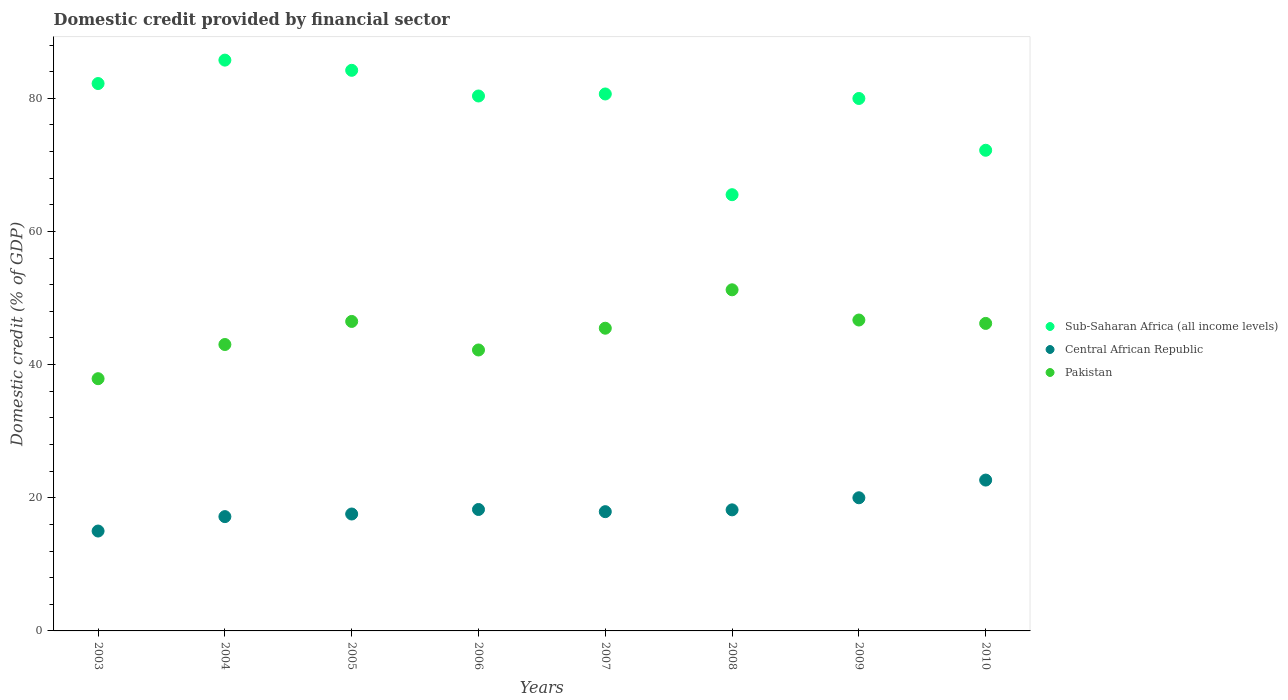How many different coloured dotlines are there?
Your response must be concise. 3. What is the domestic credit in Pakistan in 2006?
Offer a very short reply. 42.2. Across all years, what is the maximum domestic credit in Pakistan?
Offer a very short reply. 51.23. Across all years, what is the minimum domestic credit in Pakistan?
Ensure brevity in your answer.  37.88. What is the total domestic credit in Pakistan in the graph?
Your answer should be compact. 359.16. What is the difference between the domestic credit in Pakistan in 2007 and that in 2009?
Make the answer very short. -1.23. What is the difference between the domestic credit in Sub-Saharan Africa (all income levels) in 2005 and the domestic credit in Central African Republic in 2010?
Ensure brevity in your answer.  61.54. What is the average domestic credit in Pakistan per year?
Your answer should be very brief. 44.9. In the year 2008, what is the difference between the domestic credit in Central African Republic and domestic credit in Pakistan?
Provide a short and direct response. -33.05. In how many years, is the domestic credit in Sub-Saharan Africa (all income levels) greater than 12 %?
Offer a terse response. 8. What is the ratio of the domestic credit in Pakistan in 2006 to that in 2008?
Ensure brevity in your answer.  0.82. Is the difference between the domestic credit in Central African Republic in 2003 and 2010 greater than the difference between the domestic credit in Pakistan in 2003 and 2010?
Offer a terse response. Yes. What is the difference between the highest and the second highest domestic credit in Central African Republic?
Keep it short and to the point. 2.66. What is the difference between the highest and the lowest domestic credit in Central African Republic?
Give a very brief answer. 7.65. In how many years, is the domestic credit in Central African Republic greater than the average domestic credit in Central African Republic taken over all years?
Provide a succinct answer. 2. Is the sum of the domestic credit in Pakistan in 2007 and 2010 greater than the maximum domestic credit in Sub-Saharan Africa (all income levels) across all years?
Give a very brief answer. Yes. Does the domestic credit in Sub-Saharan Africa (all income levels) monotonically increase over the years?
Give a very brief answer. No. Is the domestic credit in Pakistan strictly less than the domestic credit in Sub-Saharan Africa (all income levels) over the years?
Your answer should be very brief. Yes. How many years are there in the graph?
Ensure brevity in your answer.  8. What is the difference between two consecutive major ticks on the Y-axis?
Provide a succinct answer. 20. Does the graph contain any zero values?
Your answer should be very brief. No. Does the graph contain grids?
Provide a short and direct response. No. Where does the legend appear in the graph?
Your answer should be compact. Center right. What is the title of the graph?
Offer a terse response. Domestic credit provided by financial sector. What is the label or title of the Y-axis?
Provide a succinct answer. Domestic credit (% of GDP). What is the Domestic credit (% of GDP) of Sub-Saharan Africa (all income levels) in 2003?
Provide a succinct answer. 82.22. What is the Domestic credit (% of GDP) of Central African Republic in 2003?
Provide a succinct answer. 15. What is the Domestic credit (% of GDP) in Pakistan in 2003?
Your answer should be compact. 37.88. What is the Domestic credit (% of GDP) in Sub-Saharan Africa (all income levels) in 2004?
Your answer should be very brief. 85.73. What is the Domestic credit (% of GDP) of Central African Republic in 2004?
Offer a terse response. 17.17. What is the Domestic credit (% of GDP) of Pakistan in 2004?
Ensure brevity in your answer.  43.02. What is the Domestic credit (% of GDP) in Sub-Saharan Africa (all income levels) in 2005?
Make the answer very short. 84.2. What is the Domestic credit (% of GDP) in Central African Republic in 2005?
Keep it short and to the point. 17.56. What is the Domestic credit (% of GDP) in Pakistan in 2005?
Make the answer very short. 46.48. What is the Domestic credit (% of GDP) of Sub-Saharan Africa (all income levels) in 2006?
Give a very brief answer. 80.34. What is the Domestic credit (% of GDP) of Central African Republic in 2006?
Your answer should be compact. 18.24. What is the Domestic credit (% of GDP) of Pakistan in 2006?
Offer a very short reply. 42.2. What is the Domestic credit (% of GDP) of Sub-Saharan Africa (all income levels) in 2007?
Your answer should be very brief. 80.65. What is the Domestic credit (% of GDP) of Central African Republic in 2007?
Your answer should be compact. 17.91. What is the Domestic credit (% of GDP) in Pakistan in 2007?
Keep it short and to the point. 45.46. What is the Domestic credit (% of GDP) of Sub-Saharan Africa (all income levels) in 2008?
Ensure brevity in your answer.  65.52. What is the Domestic credit (% of GDP) of Central African Republic in 2008?
Ensure brevity in your answer.  18.18. What is the Domestic credit (% of GDP) in Pakistan in 2008?
Give a very brief answer. 51.23. What is the Domestic credit (% of GDP) of Sub-Saharan Africa (all income levels) in 2009?
Your response must be concise. 79.97. What is the Domestic credit (% of GDP) of Central African Republic in 2009?
Offer a terse response. 20. What is the Domestic credit (% of GDP) of Pakistan in 2009?
Offer a very short reply. 46.7. What is the Domestic credit (% of GDP) of Sub-Saharan Africa (all income levels) in 2010?
Make the answer very short. 72.19. What is the Domestic credit (% of GDP) of Central African Republic in 2010?
Keep it short and to the point. 22.66. What is the Domestic credit (% of GDP) in Pakistan in 2010?
Keep it short and to the point. 46.19. Across all years, what is the maximum Domestic credit (% of GDP) of Sub-Saharan Africa (all income levels)?
Your answer should be compact. 85.73. Across all years, what is the maximum Domestic credit (% of GDP) of Central African Republic?
Your response must be concise. 22.66. Across all years, what is the maximum Domestic credit (% of GDP) in Pakistan?
Your answer should be very brief. 51.23. Across all years, what is the minimum Domestic credit (% of GDP) of Sub-Saharan Africa (all income levels)?
Your response must be concise. 65.52. Across all years, what is the minimum Domestic credit (% of GDP) in Central African Republic?
Ensure brevity in your answer.  15. Across all years, what is the minimum Domestic credit (% of GDP) in Pakistan?
Keep it short and to the point. 37.88. What is the total Domestic credit (% of GDP) in Sub-Saharan Africa (all income levels) in the graph?
Give a very brief answer. 630.82. What is the total Domestic credit (% of GDP) of Central African Republic in the graph?
Your answer should be very brief. 146.72. What is the total Domestic credit (% of GDP) of Pakistan in the graph?
Provide a succinct answer. 359.16. What is the difference between the Domestic credit (% of GDP) in Sub-Saharan Africa (all income levels) in 2003 and that in 2004?
Offer a terse response. -3.52. What is the difference between the Domestic credit (% of GDP) of Central African Republic in 2003 and that in 2004?
Give a very brief answer. -2.17. What is the difference between the Domestic credit (% of GDP) of Pakistan in 2003 and that in 2004?
Ensure brevity in your answer.  -5.13. What is the difference between the Domestic credit (% of GDP) of Sub-Saharan Africa (all income levels) in 2003 and that in 2005?
Your response must be concise. -1.99. What is the difference between the Domestic credit (% of GDP) in Central African Republic in 2003 and that in 2005?
Keep it short and to the point. -2.56. What is the difference between the Domestic credit (% of GDP) in Pakistan in 2003 and that in 2005?
Ensure brevity in your answer.  -8.6. What is the difference between the Domestic credit (% of GDP) of Sub-Saharan Africa (all income levels) in 2003 and that in 2006?
Your response must be concise. 1.87. What is the difference between the Domestic credit (% of GDP) of Central African Republic in 2003 and that in 2006?
Ensure brevity in your answer.  -3.24. What is the difference between the Domestic credit (% of GDP) of Pakistan in 2003 and that in 2006?
Your answer should be compact. -4.31. What is the difference between the Domestic credit (% of GDP) in Sub-Saharan Africa (all income levels) in 2003 and that in 2007?
Your answer should be compact. 1.57. What is the difference between the Domestic credit (% of GDP) of Central African Republic in 2003 and that in 2007?
Your response must be concise. -2.91. What is the difference between the Domestic credit (% of GDP) of Pakistan in 2003 and that in 2007?
Provide a succinct answer. -7.58. What is the difference between the Domestic credit (% of GDP) in Sub-Saharan Africa (all income levels) in 2003 and that in 2008?
Provide a short and direct response. 16.69. What is the difference between the Domestic credit (% of GDP) in Central African Republic in 2003 and that in 2008?
Offer a very short reply. -3.18. What is the difference between the Domestic credit (% of GDP) of Pakistan in 2003 and that in 2008?
Ensure brevity in your answer.  -13.35. What is the difference between the Domestic credit (% of GDP) in Sub-Saharan Africa (all income levels) in 2003 and that in 2009?
Your response must be concise. 2.24. What is the difference between the Domestic credit (% of GDP) in Central African Republic in 2003 and that in 2009?
Offer a terse response. -5. What is the difference between the Domestic credit (% of GDP) in Pakistan in 2003 and that in 2009?
Your answer should be very brief. -8.81. What is the difference between the Domestic credit (% of GDP) in Sub-Saharan Africa (all income levels) in 2003 and that in 2010?
Ensure brevity in your answer.  10.02. What is the difference between the Domestic credit (% of GDP) of Central African Republic in 2003 and that in 2010?
Give a very brief answer. -7.65. What is the difference between the Domestic credit (% of GDP) of Pakistan in 2003 and that in 2010?
Ensure brevity in your answer.  -8.3. What is the difference between the Domestic credit (% of GDP) of Sub-Saharan Africa (all income levels) in 2004 and that in 2005?
Your response must be concise. 1.53. What is the difference between the Domestic credit (% of GDP) in Central African Republic in 2004 and that in 2005?
Provide a short and direct response. -0.39. What is the difference between the Domestic credit (% of GDP) of Pakistan in 2004 and that in 2005?
Your response must be concise. -3.46. What is the difference between the Domestic credit (% of GDP) of Sub-Saharan Africa (all income levels) in 2004 and that in 2006?
Keep it short and to the point. 5.39. What is the difference between the Domestic credit (% of GDP) of Central African Republic in 2004 and that in 2006?
Your response must be concise. -1.07. What is the difference between the Domestic credit (% of GDP) of Pakistan in 2004 and that in 2006?
Keep it short and to the point. 0.82. What is the difference between the Domestic credit (% of GDP) in Sub-Saharan Africa (all income levels) in 2004 and that in 2007?
Your response must be concise. 5.08. What is the difference between the Domestic credit (% of GDP) in Central African Republic in 2004 and that in 2007?
Make the answer very short. -0.74. What is the difference between the Domestic credit (% of GDP) in Pakistan in 2004 and that in 2007?
Offer a terse response. -2.45. What is the difference between the Domestic credit (% of GDP) of Sub-Saharan Africa (all income levels) in 2004 and that in 2008?
Offer a terse response. 20.21. What is the difference between the Domestic credit (% of GDP) in Central African Republic in 2004 and that in 2008?
Offer a terse response. -1.02. What is the difference between the Domestic credit (% of GDP) of Pakistan in 2004 and that in 2008?
Keep it short and to the point. -8.22. What is the difference between the Domestic credit (% of GDP) in Sub-Saharan Africa (all income levels) in 2004 and that in 2009?
Offer a very short reply. 5.76. What is the difference between the Domestic credit (% of GDP) in Central African Republic in 2004 and that in 2009?
Provide a short and direct response. -2.83. What is the difference between the Domestic credit (% of GDP) of Pakistan in 2004 and that in 2009?
Offer a terse response. -3.68. What is the difference between the Domestic credit (% of GDP) of Sub-Saharan Africa (all income levels) in 2004 and that in 2010?
Offer a terse response. 13.54. What is the difference between the Domestic credit (% of GDP) of Central African Republic in 2004 and that in 2010?
Your answer should be very brief. -5.49. What is the difference between the Domestic credit (% of GDP) of Pakistan in 2004 and that in 2010?
Provide a succinct answer. -3.17. What is the difference between the Domestic credit (% of GDP) in Sub-Saharan Africa (all income levels) in 2005 and that in 2006?
Give a very brief answer. 3.86. What is the difference between the Domestic credit (% of GDP) in Central African Republic in 2005 and that in 2006?
Ensure brevity in your answer.  -0.68. What is the difference between the Domestic credit (% of GDP) of Pakistan in 2005 and that in 2006?
Make the answer very short. 4.29. What is the difference between the Domestic credit (% of GDP) in Sub-Saharan Africa (all income levels) in 2005 and that in 2007?
Your response must be concise. 3.55. What is the difference between the Domestic credit (% of GDP) of Central African Republic in 2005 and that in 2007?
Your answer should be compact. -0.35. What is the difference between the Domestic credit (% of GDP) in Pakistan in 2005 and that in 2007?
Keep it short and to the point. 1.02. What is the difference between the Domestic credit (% of GDP) of Sub-Saharan Africa (all income levels) in 2005 and that in 2008?
Your answer should be very brief. 18.68. What is the difference between the Domestic credit (% of GDP) of Central African Republic in 2005 and that in 2008?
Offer a terse response. -0.63. What is the difference between the Domestic credit (% of GDP) in Pakistan in 2005 and that in 2008?
Your answer should be very brief. -4.75. What is the difference between the Domestic credit (% of GDP) of Sub-Saharan Africa (all income levels) in 2005 and that in 2009?
Your response must be concise. 4.23. What is the difference between the Domestic credit (% of GDP) of Central African Republic in 2005 and that in 2009?
Keep it short and to the point. -2.44. What is the difference between the Domestic credit (% of GDP) in Pakistan in 2005 and that in 2009?
Your answer should be very brief. -0.21. What is the difference between the Domestic credit (% of GDP) of Sub-Saharan Africa (all income levels) in 2005 and that in 2010?
Your answer should be very brief. 12.01. What is the difference between the Domestic credit (% of GDP) of Central African Republic in 2005 and that in 2010?
Ensure brevity in your answer.  -5.1. What is the difference between the Domestic credit (% of GDP) of Pakistan in 2005 and that in 2010?
Offer a terse response. 0.3. What is the difference between the Domestic credit (% of GDP) of Sub-Saharan Africa (all income levels) in 2006 and that in 2007?
Ensure brevity in your answer.  -0.3. What is the difference between the Domestic credit (% of GDP) of Central African Republic in 2006 and that in 2007?
Make the answer very short. 0.33. What is the difference between the Domestic credit (% of GDP) in Pakistan in 2006 and that in 2007?
Offer a very short reply. -3.27. What is the difference between the Domestic credit (% of GDP) of Sub-Saharan Africa (all income levels) in 2006 and that in 2008?
Ensure brevity in your answer.  14.82. What is the difference between the Domestic credit (% of GDP) in Central African Republic in 2006 and that in 2008?
Your answer should be compact. 0.05. What is the difference between the Domestic credit (% of GDP) of Pakistan in 2006 and that in 2008?
Keep it short and to the point. -9.04. What is the difference between the Domestic credit (% of GDP) in Sub-Saharan Africa (all income levels) in 2006 and that in 2009?
Ensure brevity in your answer.  0.37. What is the difference between the Domestic credit (% of GDP) in Central African Republic in 2006 and that in 2009?
Give a very brief answer. -1.76. What is the difference between the Domestic credit (% of GDP) in Pakistan in 2006 and that in 2009?
Offer a very short reply. -4.5. What is the difference between the Domestic credit (% of GDP) in Sub-Saharan Africa (all income levels) in 2006 and that in 2010?
Ensure brevity in your answer.  8.15. What is the difference between the Domestic credit (% of GDP) in Central African Republic in 2006 and that in 2010?
Offer a very short reply. -4.42. What is the difference between the Domestic credit (% of GDP) of Pakistan in 2006 and that in 2010?
Offer a terse response. -3.99. What is the difference between the Domestic credit (% of GDP) in Sub-Saharan Africa (all income levels) in 2007 and that in 2008?
Your answer should be compact. 15.13. What is the difference between the Domestic credit (% of GDP) of Central African Republic in 2007 and that in 2008?
Keep it short and to the point. -0.27. What is the difference between the Domestic credit (% of GDP) in Pakistan in 2007 and that in 2008?
Make the answer very short. -5.77. What is the difference between the Domestic credit (% of GDP) of Sub-Saharan Africa (all income levels) in 2007 and that in 2009?
Your answer should be very brief. 0.68. What is the difference between the Domestic credit (% of GDP) in Central African Republic in 2007 and that in 2009?
Provide a succinct answer. -2.09. What is the difference between the Domestic credit (% of GDP) of Pakistan in 2007 and that in 2009?
Offer a terse response. -1.23. What is the difference between the Domestic credit (% of GDP) of Sub-Saharan Africa (all income levels) in 2007 and that in 2010?
Your answer should be compact. 8.45. What is the difference between the Domestic credit (% of GDP) of Central African Republic in 2007 and that in 2010?
Make the answer very short. -4.75. What is the difference between the Domestic credit (% of GDP) of Pakistan in 2007 and that in 2010?
Your response must be concise. -0.72. What is the difference between the Domestic credit (% of GDP) of Sub-Saharan Africa (all income levels) in 2008 and that in 2009?
Your answer should be compact. -14.45. What is the difference between the Domestic credit (% of GDP) of Central African Republic in 2008 and that in 2009?
Provide a short and direct response. -1.81. What is the difference between the Domestic credit (% of GDP) of Pakistan in 2008 and that in 2009?
Give a very brief answer. 4.54. What is the difference between the Domestic credit (% of GDP) of Sub-Saharan Africa (all income levels) in 2008 and that in 2010?
Offer a very short reply. -6.67. What is the difference between the Domestic credit (% of GDP) of Central African Republic in 2008 and that in 2010?
Your answer should be very brief. -4.47. What is the difference between the Domestic credit (% of GDP) of Pakistan in 2008 and that in 2010?
Offer a very short reply. 5.05. What is the difference between the Domestic credit (% of GDP) of Sub-Saharan Africa (all income levels) in 2009 and that in 2010?
Provide a short and direct response. 7.78. What is the difference between the Domestic credit (% of GDP) in Central African Republic in 2009 and that in 2010?
Keep it short and to the point. -2.66. What is the difference between the Domestic credit (% of GDP) of Pakistan in 2009 and that in 2010?
Provide a short and direct response. 0.51. What is the difference between the Domestic credit (% of GDP) of Sub-Saharan Africa (all income levels) in 2003 and the Domestic credit (% of GDP) of Central African Republic in 2004?
Offer a terse response. 65.05. What is the difference between the Domestic credit (% of GDP) in Sub-Saharan Africa (all income levels) in 2003 and the Domestic credit (% of GDP) in Pakistan in 2004?
Offer a very short reply. 39.2. What is the difference between the Domestic credit (% of GDP) of Central African Republic in 2003 and the Domestic credit (% of GDP) of Pakistan in 2004?
Ensure brevity in your answer.  -28.02. What is the difference between the Domestic credit (% of GDP) in Sub-Saharan Africa (all income levels) in 2003 and the Domestic credit (% of GDP) in Central African Republic in 2005?
Your response must be concise. 64.66. What is the difference between the Domestic credit (% of GDP) in Sub-Saharan Africa (all income levels) in 2003 and the Domestic credit (% of GDP) in Pakistan in 2005?
Your answer should be very brief. 35.73. What is the difference between the Domestic credit (% of GDP) in Central African Republic in 2003 and the Domestic credit (% of GDP) in Pakistan in 2005?
Your answer should be very brief. -31.48. What is the difference between the Domestic credit (% of GDP) in Sub-Saharan Africa (all income levels) in 2003 and the Domestic credit (% of GDP) in Central African Republic in 2006?
Keep it short and to the point. 63.98. What is the difference between the Domestic credit (% of GDP) of Sub-Saharan Africa (all income levels) in 2003 and the Domestic credit (% of GDP) of Pakistan in 2006?
Make the answer very short. 40.02. What is the difference between the Domestic credit (% of GDP) in Central African Republic in 2003 and the Domestic credit (% of GDP) in Pakistan in 2006?
Your answer should be very brief. -27.19. What is the difference between the Domestic credit (% of GDP) in Sub-Saharan Africa (all income levels) in 2003 and the Domestic credit (% of GDP) in Central African Republic in 2007?
Your response must be concise. 64.3. What is the difference between the Domestic credit (% of GDP) of Sub-Saharan Africa (all income levels) in 2003 and the Domestic credit (% of GDP) of Pakistan in 2007?
Keep it short and to the point. 36.75. What is the difference between the Domestic credit (% of GDP) in Central African Republic in 2003 and the Domestic credit (% of GDP) in Pakistan in 2007?
Provide a succinct answer. -30.46. What is the difference between the Domestic credit (% of GDP) of Sub-Saharan Africa (all income levels) in 2003 and the Domestic credit (% of GDP) of Central African Republic in 2008?
Ensure brevity in your answer.  64.03. What is the difference between the Domestic credit (% of GDP) in Sub-Saharan Africa (all income levels) in 2003 and the Domestic credit (% of GDP) in Pakistan in 2008?
Keep it short and to the point. 30.98. What is the difference between the Domestic credit (% of GDP) of Central African Republic in 2003 and the Domestic credit (% of GDP) of Pakistan in 2008?
Keep it short and to the point. -36.23. What is the difference between the Domestic credit (% of GDP) of Sub-Saharan Africa (all income levels) in 2003 and the Domestic credit (% of GDP) of Central African Republic in 2009?
Provide a short and direct response. 62.22. What is the difference between the Domestic credit (% of GDP) of Sub-Saharan Africa (all income levels) in 2003 and the Domestic credit (% of GDP) of Pakistan in 2009?
Provide a short and direct response. 35.52. What is the difference between the Domestic credit (% of GDP) in Central African Republic in 2003 and the Domestic credit (% of GDP) in Pakistan in 2009?
Ensure brevity in your answer.  -31.69. What is the difference between the Domestic credit (% of GDP) in Sub-Saharan Africa (all income levels) in 2003 and the Domestic credit (% of GDP) in Central African Republic in 2010?
Your answer should be compact. 59.56. What is the difference between the Domestic credit (% of GDP) in Sub-Saharan Africa (all income levels) in 2003 and the Domestic credit (% of GDP) in Pakistan in 2010?
Ensure brevity in your answer.  36.03. What is the difference between the Domestic credit (% of GDP) of Central African Republic in 2003 and the Domestic credit (% of GDP) of Pakistan in 2010?
Your answer should be compact. -31.18. What is the difference between the Domestic credit (% of GDP) of Sub-Saharan Africa (all income levels) in 2004 and the Domestic credit (% of GDP) of Central African Republic in 2005?
Ensure brevity in your answer.  68.17. What is the difference between the Domestic credit (% of GDP) in Sub-Saharan Africa (all income levels) in 2004 and the Domestic credit (% of GDP) in Pakistan in 2005?
Give a very brief answer. 39.25. What is the difference between the Domestic credit (% of GDP) of Central African Republic in 2004 and the Domestic credit (% of GDP) of Pakistan in 2005?
Offer a terse response. -29.31. What is the difference between the Domestic credit (% of GDP) in Sub-Saharan Africa (all income levels) in 2004 and the Domestic credit (% of GDP) in Central African Republic in 2006?
Offer a terse response. 67.49. What is the difference between the Domestic credit (% of GDP) in Sub-Saharan Africa (all income levels) in 2004 and the Domestic credit (% of GDP) in Pakistan in 2006?
Your response must be concise. 43.54. What is the difference between the Domestic credit (% of GDP) of Central African Republic in 2004 and the Domestic credit (% of GDP) of Pakistan in 2006?
Your response must be concise. -25.03. What is the difference between the Domestic credit (% of GDP) in Sub-Saharan Africa (all income levels) in 2004 and the Domestic credit (% of GDP) in Central African Republic in 2007?
Your answer should be compact. 67.82. What is the difference between the Domestic credit (% of GDP) in Sub-Saharan Africa (all income levels) in 2004 and the Domestic credit (% of GDP) in Pakistan in 2007?
Offer a terse response. 40.27. What is the difference between the Domestic credit (% of GDP) in Central African Republic in 2004 and the Domestic credit (% of GDP) in Pakistan in 2007?
Make the answer very short. -28.3. What is the difference between the Domestic credit (% of GDP) of Sub-Saharan Africa (all income levels) in 2004 and the Domestic credit (% of GDP) of Central African Republic in 2008?
Make the answer very short. 67.55. What is the difference between the Domestic credit (% of GDP) in Sub-Saharan Africa (all income levels) in 2004 and the Domestic credit (% of GDP) in Pakistan in 2008?
Offer a very short reply. 34.5. What is the difference between the Domestic credit (% of GDP) in Central African Republic in 2004 and the Domestic credit (% of GDP) in Pakistan in 2008?
Give a very brief answer. -34.07. What is the difference between the Domestic credit (% of GDP) in Sub-Saharan Africa (all income levels) in 2004 and the Domestic credit (% of GDP) in Central African Republic in 2009?
Provide a succinct answer. 65.73. What is the difference between the Domestic credit (% of GDP) in Sub-Saharan Africa (all income levels) in 2004 and the Domestic credit (% of GDP) in Pakistan in 2009?
Your response must be concise. 39.04. What is the difference between the Domestic credit (% of GDP) of Central African Republic in 2004 and the Domestic credit (% of GDP) of Pakistan in 2009?
Provide a succinct answer. -29.53. What is the difference between the Domestic credit (% of GDP) of Sub-Saharan Africa (all income levels) in 2004 and the Domestic credit (% of GDP) of Central African Republic in 2010?
Your response must be concise. 63.08. What is the difference between the Domestic credit (% of GDP) in Sub-Saharan Africa (all income levels) in 2004 and the Domestic credit (% of GDP) in Pakistan in 2010?
Your answer should be very brief. 39.55. What is the difference between the Domestic credit (% of GDP) of Central African Republic in 2004 and the Domestic credit (% of GDP) of Pakistan in 2010?
Offer a terse response. -29.02. What is the difference between the Domestic credit (% of GDP) in Sub-Saharan Africa (all income levels) in 2005 and the Domestic credit (% of GDP) in Central African Republic in 2006?
Your answer should be compact. 65.96. What is the difference between the Domestic credit (% of GDP) of Sub-Saharan Africa (all income levels) in 2005 and the Domestic credit (% of GDP) of Pakistan in 2006?
Keep it short and to the point. 42. What is the difference between the Domestic credit (% of GDP) of Central African Republic in 2005 and the Domestic credit (% of GDP) of Pakistan in 2006?
Make the answer very short. -24.64. What is the difference between the Domestic credit (% of GDP) in Sub-Saharan Africa (all income levels) in 2005 and the Domestic credit (% of GDP) in Central African Republic in 2007?
Provide a short and direct response. 66.29. What is the difference between the Domestic credit (% of GDP) of Sub-Saharan Africa (all income levels) in 2005 and the Domestic credit (% of GDP) of Pakistan in 2007?
Your answer should be compact. 38.74. What is the difference between the Domestic credit (% of GDP) of Central African Republic in 2005 and the Domestic credit (% of GDP) of Pakistan in 2007?
Offer a very short reply. -27.91. What is the difference between the Domestic credit (% of GDP) in Sub-Saharan Africa (all income levels) in 2005 and the Domestic credit (% of GDP) in Central African Republic in 2008?
Make the answer very short. 66.02. What is the difference between the Domestic credit (% of GDP) of Sub-Saharan Africa (all income levels) in 2005 and the Domestic credit (% of GDP) of Pakistan in 2008?
Your response must be concise. 32.97. What is the difference between the Domestic credit (% of GDP) in Central African Republic in 2005 and the Domestic credit (% of GDP) in Pakistan in 2008?
Provide a succinct answer. -33.68. What is the difference between the Domestic credit (% of GDP) of Sub-Saharan Africa (all income levels) in 2005 and the Domestic credit (% of GDP) of Central African Republic in 2009?
Your answer should be compact. 64.2. What is the difference between the Domestic credit (% of GDP) of Sub-Saharan Africa (all income levels) in 2005 and the Domestic credit (% of GDP) of Pakistan in 2009?
Offer a very short reply. 37.5. What is the difference between the Domestic credit (% of GDP) of Central African Republic in 2005 and the Domestic credit (% of GDP) of Pakistan in 2009?
Your answer should be compact. -29.14. What is the difference between the Domestic credit (% of GDP) of Sub-Saharan Africa (all income levels) in 2005 and the Domestic credit (% of GDP) of Central African Republic in 2010?
Your answer should be compact. 61.54. What is the difference between the Domestic credit (% of GDP) in Sub-Saharan Africa (all income levels) in 2005 and the Domestic credit (% of GDP) in Pakistan in 2010?
Provide a short and direct response. 38.01. What is the difference between the Domestic credit (% of GDP) of Central African Republic in 2005 and the Domestic credit (% of GDP) of Pakistan in 2010?
Provide a short and direct response. -28.63. What is the difference between the Domestic credit (% of GDP) in Sub-Saharan Africa (all income levels) in 2006 and the Domestic credit (% of GDP) in Central African Republic in 2007?
Give a very brief answer. 62.43. What is the difference between the Domestic credit (% of GDP) in Sub-Saharan Africa (all income levels) in 2006 and the Domestic credit (% of GDP) in Pakistan in 2007?
Offer a very short reply. 34.88. What is the difference between the Domestic credit (% of GDP) in Central African Republic in 2006 and the Domestic credit (% of GDP) in Pakistan in 2007?
Ensure brevity in your answer.  -27.23. What is the difference between the Domestic credit (% of GDP) in Sub-Saharan Africa (all income levels) in 2006 and the Domestic credit (% of GDP) in Central African Republic in 2008?
Provide a succinct answer. 62.16. What is the difference between the Domestic credit (% of GDP) of Sub-Saharan Africa (all income levels) in 2006 and the Domestic credit (% of GDP) of Pakistan in 2008?
Keep it short and to the point. 29.11. What is the difference between the Domestic credit (% of GDP) in Central African Republic in 2006 and the Domestic credit (% of GDP) in Pakistan in 2008?
Provide a succinct answer. -33. What is the difference between the Domestic credit (% of GDP) in Sub-Saharan Africa (all income levels) in 2006 and the Domestic credit (% of GDP) in Central African Republic in 2009?
Your answer should be very brief. 60.35. What is the difference between the Domestic credit (% of GDP) of Sub-Saharan Africa (all income levels) in 2006 and the Domestic credit (% of GDP) of Pakistan in 2009?
Provide a short and direct response. 33.65. What is the difference between the Domestic credit (% of GDP) in Central African Republic in 2006 and the Domestic credit (% of GDP) in Pakistan in 2009?
Your answer should be very brief. -28.46. What is the difference between the Domestic credit (% of GDP) in Sub-Saharan Africa (all income levels) in 2006 and the Domestic credit (% of GDP) in Central African Republic in 2010?
Your answer should be very brief. 57.69. What is the difference between the Domestic credit (% of GDP) of Sub-Saharan Africa (all income levels) in 2006 and the Domestic credit (% of GDP) of Pakistan in 2010?
Provide a succinct answer. 34.16. What is the difference between the Domestic credit (% of GDP) of Central African Republic in 2006 and the Domestic credit (% of GDP) of Pakistan in 2010?
Offer a terse response. -27.95. What is the difference between the Domestic credit (% of GDP) of Sub-Saharan Africa (all income levels) in 2007 and the Domestic credit (% of GDP) of Central African Republic in 2008?
Your answer should be very brief. 62.46. What is the difference between the Domestic credit (% of GDP) in Sub-Saharan Africa (all income levels) in 2007 and the Domestic credit (% of GDP) in Pakistan in 2008?
Provide a succinct answer. 29.41. What is the difference between the Domestic credit (% of GDP) of Central African Republic in 2007 and the Domestic credit (% of GDP) of Pakistan in 2008?
Make the answer very short. -33.32. What is the difference between the Domestic credit (% of GDP) of Sub-Saharan Africa (all income levels) in 2007 and the Domestic credit (% of GDP) of Central African Republic in 2009?
Ensure brevity in your answer.  60.65. What is the difference between the Domestic credit (% of GDP) in Sub-Saharan Africa (all income levels) in 2007 and the Domestic credit (% of GDP) in Pakistan in 2009?
Ensure brevity in your answer.  33.95. What is the difference between the Domestic credit (% of GDP) of Central African Republic in 2007 and the Domestic credit (% of GDP) of Pakistan in 2009?
Make the answer very short. -28.79. What is the difference between the Domestic credit (% of GDP) in Sub-Saharan Africa (all income levels) in 2007 and the Domestic credit (% of GDP) in Central African Republic in 2010?
Provide a succinct answer. 57.99. What is the difference between the Domestic credit (% of GDP) in Sub-Saharan Africa (all income levels) in 2007 and the Domestic credit (% of GDP) in Pakistan in 2010?
Ensure brevity in your answer.  34.46. What is the difference between the Domestic credit (% of GDP) in Central African Republic in 2007 and the Domestic credit (% of GDP) in Pakistan in 2010?
Ensure brevity in your answer.  -28.28. What is the difference between the Domestic credit (% of GDP) in Sub-Saharan Africa (all income levels) in 2008 and the Domestic credit (% of GDP) in Central African Republic in 2009?
Your answer should be very brief. 45.52. What is the difference between the Domestic credit (% of GDP) in Sub-Saharan Africa (all income levels) in 2008 and the Domestic credit (% of GDP) in Pakistan in 2009?
Your answer should be compact. 18.82. What is the difference between the Domestic credit (% of GDP) in Central African Republic in 2008 and the Domestic credit (% of GDP) in Pakistan in 2009?
Make the answer very short. -28.51. What is the difference between the Domestic credit (% of GDP) of Sub-Saharan Africa (all income levels) in 2008 and the Domestic credit (% of GDP) of Central African Republic in 2010?
Offer a very short reply. 42.86. What is the difference between the Domestic credit (% of GDP) of Sub-Saharan Africa (all income levels) in 2008 and the Domestic credit (% of GDP) of Pakistan in 2010?
Provide a succinct answer. 19.33. What is the difference between the Domestic credit (% of GDP) in Central African Republic in 2008 and the Domestic credit (% of GDP) in Pakistan in 2010?
Provide a succinct answer. -28. What is the difference between the Domestic credit (% of GDP) of Sub-Saharan Africa (all income levels) in 2009 and the Domestic credit (% of GDP) of Central African Republic in 2010?
Give a very brief answer. 57.32. What is the difference between the Domestic credit (% of GDP) in Sub-Saharan Africa (all income levels) in 2009 and the Domestic credit (% of GDP) in Pakistan in 2010?
Ensure brevity in your answer.  33.78. What is the difference between the Domestic credit (% of GDP) of Central African Republic in 2009 and the Domestic credit (% of GDP) of Pakistan in 2010?
Give a very brief answer. -26.19. What is the average Domestic credit (% of GDP) of Sub-Saharan Africa (all income levels) per year?
Keep it short and to the point. 78.85. What is the average Domestic credit (% of GDP) of Central African Republic per year?
Ensure brevity in your answer.  18.34. What is the average Domestic credit (% of GDP) in Pakistan per year?
Make the answer very short. 44.9. In the year 2003, what is the difference between the Domestic credit (% of GDP) in Sub-Saharan Africa (all income levels) and Domestic credit (% of GDP) in Central African Republic?
Provide a succinct answer. 67.21. In the year 2003, what is the difference between the Domestic credit (% of GDP) in Sub-Saharan Africa (all income levels) and Domestic credit (% of GDP) in Pakistan?
Ensure brevity in your answer.  44.33. In the year 2003, what is the difference between the Domestic credit (% of GDP) of Central African Republic and Domestic credit (% of GDP) of Pakistan?
Your answer should be very brief. -22.88. In the year 2004, what is the difference between the Domestic credit (% of GDP) in Sub-Saharan Africa (all income levels) and Domestic credit (% of GDP) in Central African Republic?
Make the answer very short. 68.56. In the year 2004, what is the difference between the Domestic credit (% of GDP) of Sub-Saharan Africa (all income levels) and Domestic credit (% of GDP) of Pakistan?
Your response must be concise. 42.71. In the year 2004, what is the difference between the Domestic credit (% of GDP) of Central African Republic and Domestic credit (% of GDP) of Pakistan?
Make the answer very short. -25.85. In the year 2005, what is the difference between the Domestic credit (% of GDP) in Sub-Saharan Africa (all income levels) and Domestic credit (% of GDP) in Central African Republic?
Provide a short and direct response. 66.64. In the year 2005, what is the difference between the Domestic credit (% of GDP) of Sub-Saharan Africa (all income levels) and Domestic credit (% of GDP) of Pakistan?
Give a very brief answer. 37.72. In the year 2005, what is the difference between the Domestic credit (% of GDP) of Central African Republic and Domestic credit (% of GDP) of Pakistan?
Offer a terse response. -28.92. In the year 2006, what is the difference between the Domestic credit (% of GDP) in Sub-Saharan Africa (all income levels) and Domestic credit (% of GDP) in Central African Republic?
Your answer should be compact. 62.11. In the year 2006, what is the difference between the Domestic credit (% of GDP) in Sub-Saharan Africa (all income levels) and Domestic credit (% of GDP) in Pakistan?
Your response must be concise. 38.15. In the year 2006, what is the difference between the Domestic credit (% of GDP) of Central African Republic and Domestic credit (% of GDP) of Pakistan?
Your response must be concise. -23.96. In the year 2007, what is the difference between the Domestic credit (% of GDP) of Sub-Saharan Africa (all income levels) and Domestic credit (% of GDP) of Central African Republic?
Give a very brief answer. 62.74. In the year 2007, what is the difference between the Domestic credit (% of GDP) in Sub-Saharan Africa (all income levels) and Domestic credit (% of GDP) in Pakistan?
Your response must be concise. 35.18. In the year 2007, what is the difference between the Domestic credit (% of GDP) of Central African Republic and Domestic credit (% of GDP) of Pakistan?
Ensure brevity in your answer.  -27.55. In the year 2008, what is the difference between the Domestic credit (% of GDP) of Sub-Saharan Africa (all income levels) and Domestic credit (% of GDP) of Central African Republic?
Offer a very short reply. 47.34. In the year 2008, what is the difference between the Domestic credit (% of GDP) of Sub-Saharan Africa (all income levels) and Domestic credit (% of GDP) of Pakistan?
Keep it short and to the point. 14.29. In the year 2008, what is the difference between the Domestic credit (% of GDP) of Central African Republic and Domestic credit (% of GDP) of Pakistan?
Provide a succinct answer. -33.05. In the year 2009, what is the difference between the Domestic credit (% of GDP) of Sub-Saharan Africa (all income levels) and Domestic credit (% of GDP) of Central African Republic?
Your answer should be compact. 59.97. In the year 2009, what is the difference between the Domestic credit (% of GDP) in Sub-Saharan Africa (all income levels) and Domestic credit (% of GDP) in Pakistan?
Provide a succinct answer. 33.27. In the year 2009, what is the difference between the Domestic credit (% of GDP) of Central African Republic and Domestic credit (% of GDP) of Pakistan?
Ensure brevity in your answer.  -26.7. In the year 2010, what is the difference between the Domestic credit (% of GDP) of Sub-Saharan Africa (all income levels) and Domestic credit (% of GDP) of Central African Republic?
Provide a short and direct response. 49.54. In the year 2010, what is the difference between the Domestic credit (% of GDP) of Sub-Saharan Africa (all income levels) and Domestic credit (% of GDP) of Pakistan?
Give a very brief answer. 26.01. In the year 2010, what is the difference between the Domestic credit (% of GDP) of Central African Republic and Domestic credit (% of GDP) of Pakistan?
Offer a terse response. -23.53. What is the ratio of the Domestic credit (% of GDP) of Sub-Saharan Africa (all income levels) in 2003 to that in 2004?
Your response must be concise. 0.96. What is the ratio of the Domestic credit (% of GDP) of Central African Republic in 2003 to that in 2004?
Ensure brevity in your answer.  0.87. What is the ratio of the Domestic credit (% of GDP) in Pakistan in 2003 to that in 2004?
Your answer should be compact. 0.88. What is the ratio of the Domestic credit (% of GDP) of Sub-Saharan Africa (all income levels) in 2003 to that in 2005?
Your answer should be compact. 0.98. What is the ratio of the Domestic credit (% of GDP) of Central African Republic in 2003 to that in 2005?
Offer a terse response. 0.85. What is the ratio of the Domestic credit (% of GDP) of Pakistan in 2003 to that in 2005?
Give a very brief answer. 0.81. What is the ratio of the Domestic credit (% of GDP) in Sub-Saharan Africa (all income levels) in 2003 to that in 2006?
Your answer should be very brief. 1.02. What is the ratio of the Domestic credit (% of GDP) in Central African Republic in 2003 to that in 2006?
Keep it short and to the point. 0.82. What is the ratio of the Domestic credit (% of GDP) of Pakistan in 2003 to that in 2006?
Provide a succinct answer. 0.9. What is the ratio of the Domestic credit (% of GDP) of Sub-Saharan Africa (all income levels) in 2003 to that in 2007?
Provide a succinct answer. 1.02. What is the ratio of the Domestic credit (% of GDP) in Central African Republic in 2003 to that in 2007?
Offer a terse response. 0.84. What is the ratio of the Domestic credit (% of GDP) in Sub-Saharan Africa (all income levels) in 2003 to that in 2008?
Your response must be concise. 1.25. What is the ratio of the Domestic credit (% of GDP) in Central African Republic in 2003 to that in 2008?
Your response must be concise. 0.82. What is the ratio of the Domestic credit (% of GDP) of Pakistan in 2003 to that in 2008?
Make the answer very short. 0.74. What is the ratio of the Domestic credit (% of GDP) in Sub-Saharan Africa (all income levels) in 2003 to that in 2009?
Ensure brevity in your answer.  1.03. What is the ratio of the Domestic credit (% of GDP) in Central African Republic in 2003 to that in 2009?
Give a very brief answer. 0.75. What is the ratio of the Domestic credit (% of GDP) of Pakistan in 2003 to that in 2009?
Keep it short and to the point. 0.81. What is the ratio of the Domestic credit (% of GDP) in Sub-Saharan Africa (all income levels) in 2003 to that in 2010?
Provide a short and direct response. 1.14. What is the ratio of the Domestic credit (% of GDP) of Central African Republic in 2003 to that in 2010?
Keep it short and to the point. 0.66. What is the ratio of the Domestic credit (% of GDP) in Pakistan in 2003 to that in 2010?
Your answer should be very brief. 0.82. What is the ratio of the Domestic credit (% of GDP) of Sub-Saharan Africa (all income levels) in 2004 to that in 2005?
Give a very brief answer. 1.02. What is the ratio of the Domestic credit (% of GDP) in Central African Republic in 2004 to that in 2005?
Offer a very short reply. 0.98. What is the ratio of the Domestic credit (% of GDP) in Pakistan in 2004 to that in 2005?
Your response must be concise. 0.93. What is the ratio of the Domestic credit (% of GDP) of Sub-Saharan Africa (all income levels) in 2004 to that in 2006?
Your answer should be very brief. 1.07. What is the ratio of the Domestic credit (% of GDP) of Central African Republic in 2004 to that in 2006?
Offer a terse response. 0.94. What is the ratio of the Domestic credit (% of GDP) in Pakistan in 2004 to that in 2006?
Offer a very short reply. 1.02. What is the ratio of the Domestic credit (% of GDP) in Sub-Saharan Africa (all income levels) in 2004 to that in 2007?
Your response must be concise. 1.06. What is the ratio of the Domestic credit (% of GDP) of Central African Republic in 2004 to that in 2007?
Your response must be concise. 0.96. What is the ratio of the Domestic credit (% of GDP) in Pakistan in 2004 to that in 2007?
Provide a short and direct response. 0.95. What is the ratio of the Domestic credit (% of GDP) in Sub-Saharan Africa (all income levels) in 2004 to that in 2008?
Offer a terse response. 1.31. What is the ratio of the Domestic credit (% of GDP) in Central African Republic in 2004 to that in 2008?
Provide a short and direct response. 0.94. What is the ratio of the Domestic credit (% of GDP) in Pakistan in 2004 to that in 2008?
Offer a very short reply. 0.84. What is the ratio of the Domestic credit (% of GDP) of Sub-Saharan Africa (all income levels) in 2004 to that in 2009?
Provide a succinct answer. 1.07. What is the ratio of the Domestic credit (% of GDP) in Central African Republic in 2004 to that in 2009?
Provide a succinct answer. 0.86. What is the ratio of the Domestic credit (% of GDP) of Pakistan in 2004 to that in 2009?
Offer a terse response. 0.92. What is the ratio of the Domestic credit (% of GDP) in Sub-Saharan Africa (all income levels) in 2004 to that in 2010?
Ensure brevity in your answer.  1.19. What is the ratio of the Domestic credit (% of GDP) of Central African Republic in 2004 to that in 2010?
Provide a succinct answer. 0.76. What is the ratio of the Domestic credit (% of GDP) in Pakistan in 2004 to that in 2010?
Your answer should be very brief. 0.93. What is the ratio of the Domestic credit (% of GDP) of Sub-Saharan Africa (all income levels) in 2005 to that in 2006?
Your answer should be very brief. 1.05. What is the ratio of the Domestic credit (% of GDP) in Central African Republic in 2005 to that in 2006?
Your response must be concise. 0.96. What is the ratio of the Domestic credit (% of GDP) in Pakistan in 2005 to that in 2006?
Ensure brevity in your answer.  1.1. What is the ratio of the Domestic credit (% of GDP) of Sub-Saharan Africa (all income levels) in 2005 to that in 2007?
Your answer should be compact. 1.04. What is the ratio of the Domestic credit (% of GDP) of Central African Republic in 2005 to that in 2007?
Make the answer very short. 0.98. What is the ratio of the Domestic credit (% of GDP) of Pakistan in 2005 to that in 2007?
Give a very brief answer. 1.02. What is the ratio of the Domestic credit (% of GDP) of Sub-Saharan Africa (all income levels) in 2005 to that in 2008?
Give a very brief answer. 1.29. What is the ratio of the Domestic credit (% of GDP) of Central African Republic in 2005 to that in 2008?
Provide a succinct answer. 0.97. What is the ratio of the Domestic credit (% of GDP) in Pakistan in 2005 to that in 2008?
Provide a short and direct response. 0.91. What is the ratio of the Domestic credit (% of GDP) of Sub-Saharan Africa (all income levels) in 2005 to that in 2009?
Your answer should be compact. 1.05. What is the ratio of the Domestic credit (% of GDP) in Central African Republic in 2005 to that in 2009?
Keep it short and to the point. 0.88. What is the ratio of the Domestic credit (% of GDP) of Pakistan in 2005 to that in 2009?
Your answer should be compact. 1. What is the ratio of the Domestic credit (% of GDP) of Sub-Saharan Africa (all income levels) in 2005 to that in 2010?
Provide a succinct answer. 1.17. What is the ratio of the Domestic credit (% of GDP) in Central African Republic in 2005 to that in 2010?
Provide a succinct answer. 0.78. What is the ratio of the Domestic credit (% of GDP) of Pakistan in 2005 to that in 2010?
Your answer should be very brief. 1.01. What is the ratio of the Domestic credit (% of GDP) in Sub-Saharan Africa (all income levels) in 2006 to that in 2007?
Offer a terse response. 1. What is the ratio of the Domestic credit (% of GDP) of Central African Republic in 2006 to that in 2007?
Provide a short and direct response. 1.02. What is the ratio of the Domestic credit (% of GDP) of Pakistan in 2006 to that in 2007?
Your response must be concise. 0.93. What is the ratio of the Domestic credit (% of GDP) of Sub-Saharan Africa (all income levels) in 2006 to that in 2008?
Your answer should be compact. 1.23. What is the ratio of the Domestic credit (% of GDP) of Pakistan in 2006 to that in 2008?
Make the answer very short. 0.82. What is the ratio of the Domestic credit (% of GDP) of Central African Republic in 2006 to that in 2009?
Keep it short and to the point. 0.91. What is the ratio of the Domestic credit (% of GDP) in Pakistan in 2006 to that in 2009?
Make the answer very short. 0.9. What is the ratio of the Domestic credit (% of GDP) in Sub-Saharan Africa (all income levels) in 2006 to that in 2010?
Your answer should be very brief. 1.11. What is the ratio of the Domestic credit (% of GDP) of Central African Republic in 2006 to that in 2010?
Ensure brevity in your answer.  0.81. What is the ratio of the Domestic credit (% of GDP) in Pakistan in 2006 to that in 2010?
Your response must be concise. 0.91. What is the ratio of the Domestic credit (% of GDP) in Sub-Saharan Africa (all income levels) in 2007 to that in 2008?
Offer a very short reply. 1.23. What is the ratio of the Domestic credit (% of GDP) of Pakistan in 2007 to that in 2008?
Offer a terse response. 0.89. What is the ratio of the Domestic credit (% of GDP) in Sub-Saharan Africa (all income levels) in 2007 to that in 2009?
Your response must be concise. 1.01. What is the ratio of the Domestic credit (% of GDP) of Central African Republic in 2007 to that in 2009?
Provide a short and direct response. 0.9. What is the ratio of the Domestic credit (% of GDP) of Pakistan in 2007 to that in 2009?
Offer a very short reply. 0.97. What is the ratio of the Domestic credit (% of GDP) of Sub-Saharan Africa (all income levels) in 2007 to that in 2010?
Give a very brief answer. 1.12. What is the ratio of the Domestic credit (% of GDP) of Central African Republic in 2007 to that in 2010?
Give a very brief answer. 0.79. What is the ratio of the Domestic credit (% of GDP) of Pakistan in 2007 to that in 2010?
Make the answer very short. 0.98. What is the ratio of the Domestic credit (% of GDP) in Sub-Saharan Africa (all income levels) in 2008 to that in 2009?
Provide a succinct answer. 0.82. What is the ratio of the Domestic credit (% of GDP) in Central African Republic in 2008 to that in 2009?
Provide a short and direct response. 0.91. What is the ratio of the Domestic credit (% of GDP) in Pakistan in 2008 to that in 2009?
Your answer should be compact. 1.1. What is the ratio of the Domestic credit (% of GDP) of Sub-Saharan Africa (all income levels) in 2008 to that in 2010?
Provide a succinct answer. 0.91. What is the ratio of the Domestic credit (% of GDP) of Central African Republic in 2008 to that in 2010?
Keep it short and to the point. 0.8. What is the ratio of the Domestic credit (% of GDP) of Pakistan in 2008 to that in 2010?
Make the answer very short. 1.11. What is the ratio of the Domestic credit (% of GDP) in Sub-Saharan Africa (all income levels) in 2009 to that in 2010?
Provide a short and direct response. 1.11. What is the ratio of the Domestic credit (% of GDP) in Central African Republic in 2009 to that in 2010?
Your answer should be very brief. 0.88. What is the difference between the highest and the second highest Domestic credit (% of GDP) of Sub-Saharan Africa (all income levels)?
Your response must be concise. 1.53. What is the difference between the highest and the second highest Domestic credit (% of GDP) in Central African Republic?
Make the answer very short. 2.66. What is the difference between the highest and the second highest Domestic credit (% of GDP) of Pakistan?
Offer a terse response. 4.54. What is the difference between the highest and the lowest Domestic credit (% of GDP) of Sub-Saharan Africa (all income levels)?
Offer a terse response. 20.21. What is the difference between the highest and the lowest Domestic credit (% of GDP) in Central African Republic?
Provide a succinct answer. 7.65. What is the difference between the highest and the lowest Domestic credit (% of GDP) of Pakistan?
Ensure brevity in your answer.  13.35. 